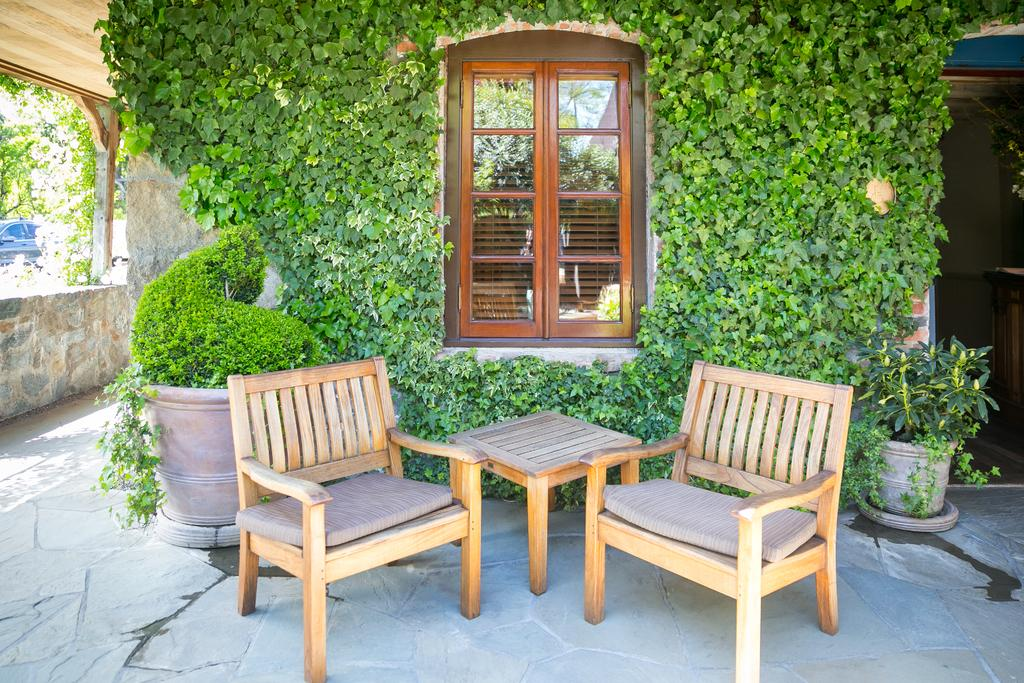What type of furniture is visible in the image? There is a table and chairs in the image. Where are the table and chairs located? The table and chairs are on the floor. What is the setting of the image? The setting appears to be a balcony. What can be seen in the middle of the image? There is a window in the middle of the image. What type of vegetation is present in the image? Plants are present all over the sides of the image. What type of disease is affecting the plants in the image? There is no indication of any disease affecting the plants in the image. Can you tell me how the woman is expanding her knowledge in the image? There is no woman present in the image, and therefore no such activity can be observed. 